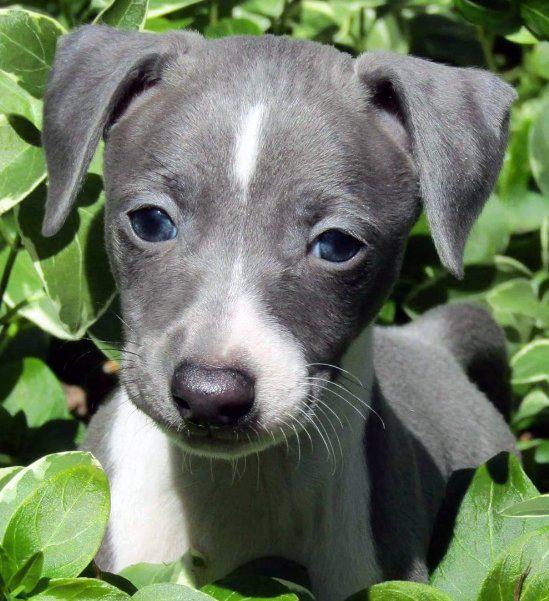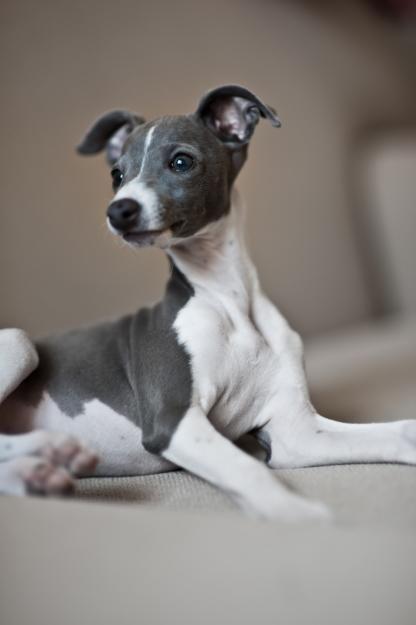The first image is the image on the left, the second image is the image on the right. Evaluate the accuracy of this statement regarding the images: "One of the dogs is in green vegetation.". Is it true? Answer yes or no. Yes. The first image is the image on the left, the second image is the image on the right. For the images shown, is this caption "There are more hound dogs in the right image than in the left." true? Answer yes or no. No. The first image is the image on the left, the second image is the image on the right. Considering the images on both sides, is "Each image contains a single dog, and all dogs are charcoal gray with white markings." valid? Answer yes or no. Yes. The first image is the image on the left, the second image is the image on the right. Examine the images to the left and right. Is the description "There is a dog posing near some green leaves." accurate? Answer yes or no. Yes. 